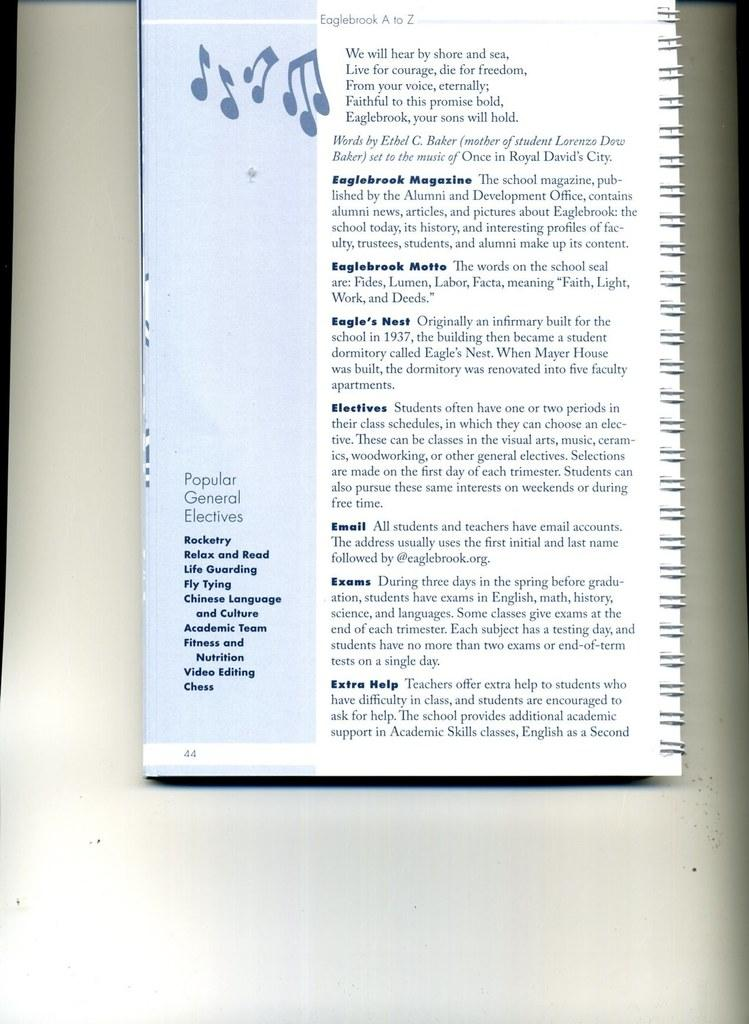<image>
Describe the image concisely. A musical book open to page 44 which is about popular general electives. 